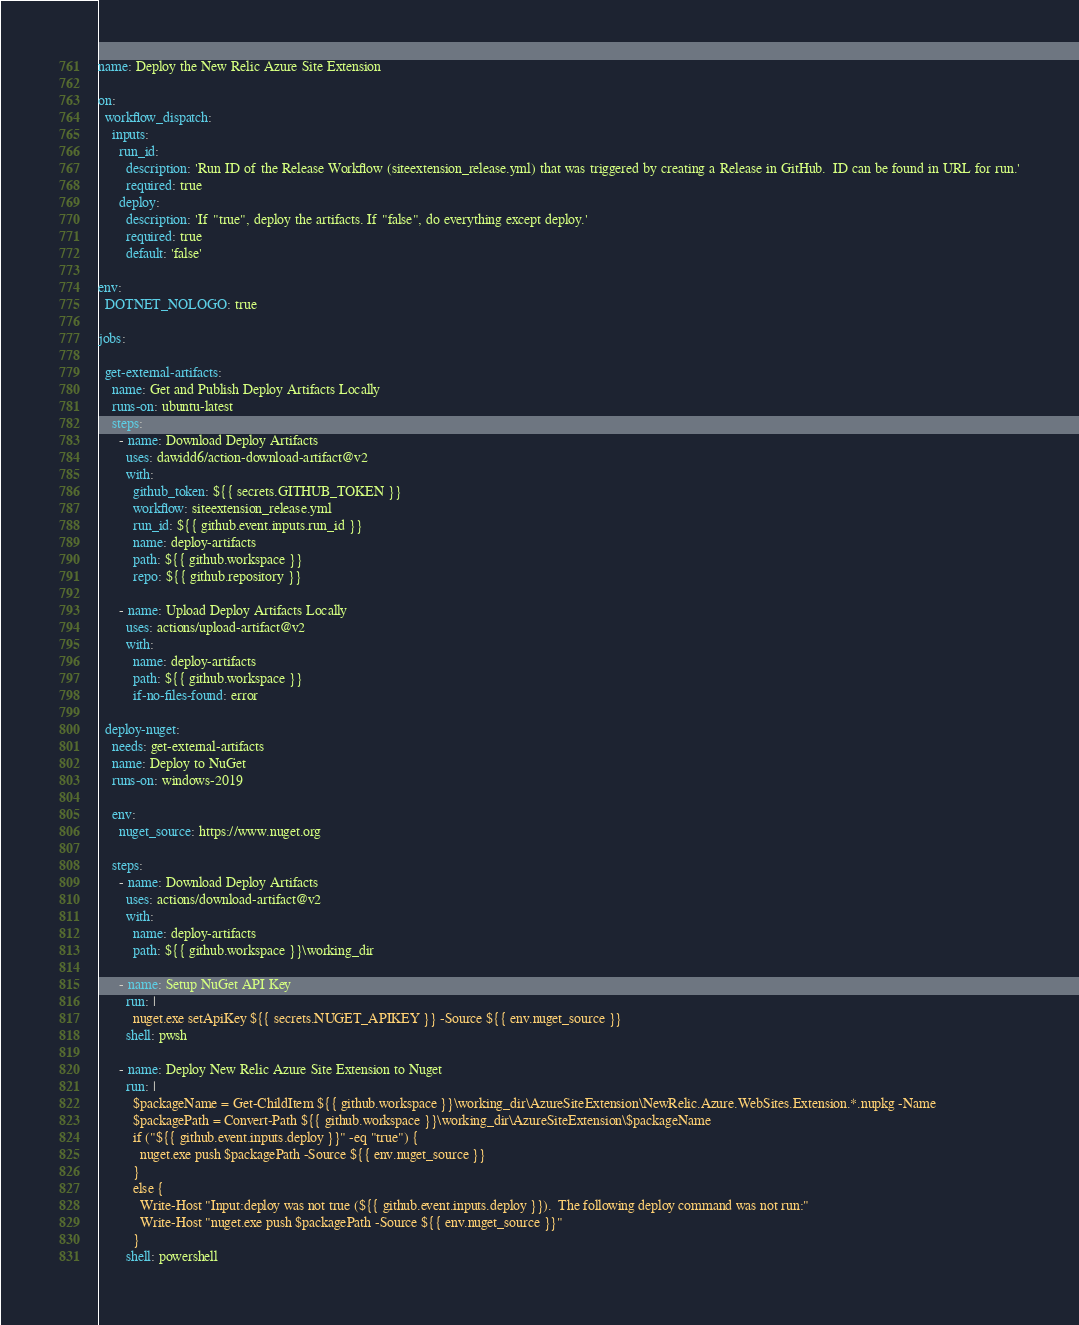Convert code to text. <code><loc_0><loc_0><loc_500><loc_500><_YAML_>name: Deploy the New Relic Azure Site Extension

on:
  workflow_dispatch:
    inputs:
      run_id:
        description: 'Run ID of the Release Workflow (siteextension_release.yml) that was triggered by creating a Release in GitHub.  ID can be found in URL for run.'
        required: true
      deploy:
        description: 'If "true", deploy the artifacts. If "false", do everything except deploy.'
        required: true
        default: 'false'

env:
  DOTNET_NOLOGO: true

jobs:

  get-external-artifacts:
    name: Get and Publish Deploy Artifacts Locally
    runs-on: ubuntu-latest
    steps:
      - name: Download Deploy Artifacts
        uses: dawidd6/action-download-artifact@v2
        with:
          github_token: ${{ secrets.GITHUB_TOKEN }}
          workflow: siteextension_release.yml
          run_id: ${{ github.event.inputs.run_id }}
          name: deploy-artifacts
          path: ${{ github.workspace }}
          repo: ${{ github.repository }}
      
      - name: Upload Deploy Artifacts Locally
        uses: actions/upload-artifact@v2
        with:
          name: deploy-artifacts
          path: ${{ github.workspace }}
          if-no-files-found: error
  
  deploy-nuget:
    needs: get-external-artifacts
    name: Deploy to NuGet
    runs-on: windows-2019

    env:
      nuget_source: https://www.nuget.org

    steps:
      - name: Download Deploy Artifacts
        uses: actions/download-artifact@v2
        with:
          name: deploy-artifacts
          path: ${{ github.workspace }}\working_dir

      - name: Setup NuGet API Key
        run: |
          nuget.exe setApiKey ${{ secrets.NUGET_APIKEY }} -Source ${{ env.nuget_source }}
        shell: pwsh

      - name: Deploy New Relic Azure Site Extension to Nuget
        run: |
          $packageName = Get-ChildItem ${{ github.workspace }}\working_dir\AzureSiteExtension\NewRelic.Azure.WebSites.Extension.*.nupkg -Name
          $packagePath = Convert-Path ${{ github.workspace }}\working_dir\AzureSiteExtension\$packageName
          if ("${{ github.event.inputs.deploy }}" -eq "true") {
            nuget.exe push $packagePath -Source ${{ env.nuget_source }}
          }
          else {
            Write-Host "Input:deploy was not true (${{ github.event.inputs.deploy }}).  The following deploy command was not run:"
            Write-Host "nuget.exe push $packagePath -Source ${{ env.nuget_source }}"
          }
        shell: powershell
</code> 